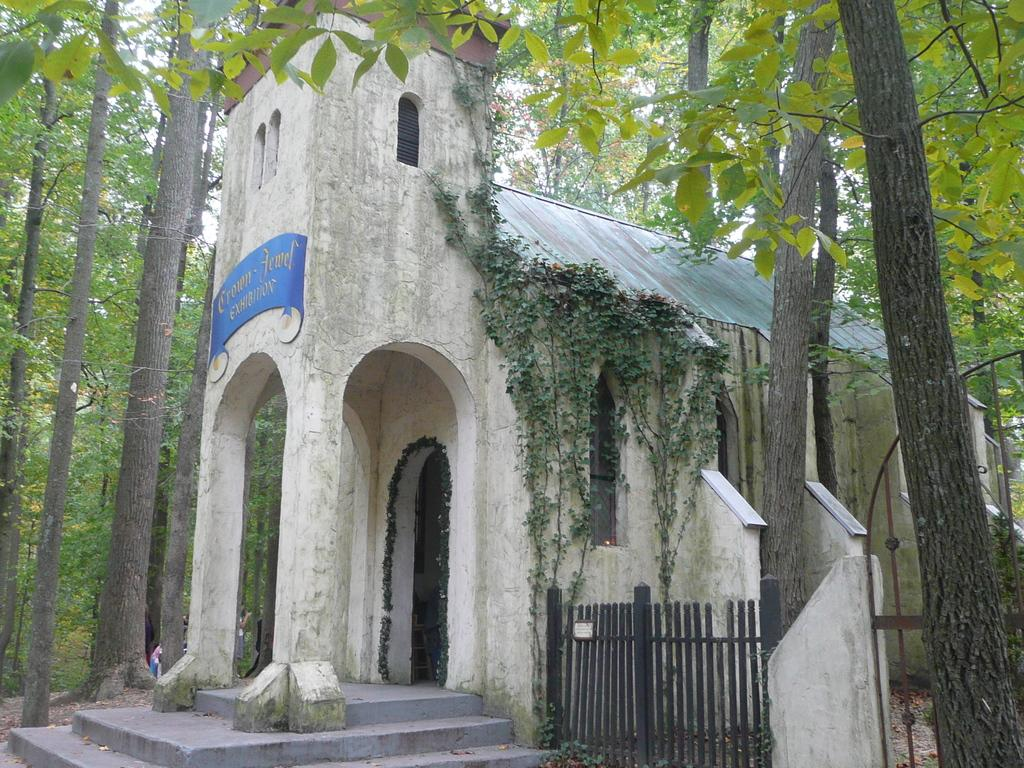What type of structure is present in the image? There is a building in the image. What type of vegetation is visible in the image? There are green color trees in the image. Can you tell me how the building expresses anger in the image? Buildings do not express emotions like anger; they are inanimate structures. What type of material is the lead used for in the image? There is no mention of lead or any material in the image. 